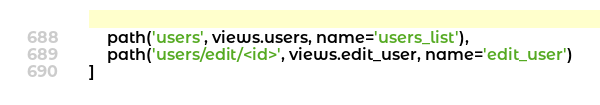<code> <loc_0><loc_0><loc_500><loc_500><_Python_>    path('users', views.users, name='users_list'),
    path('users/edit/<id>', views.edit_user, name='edit_user')
]
</code> 